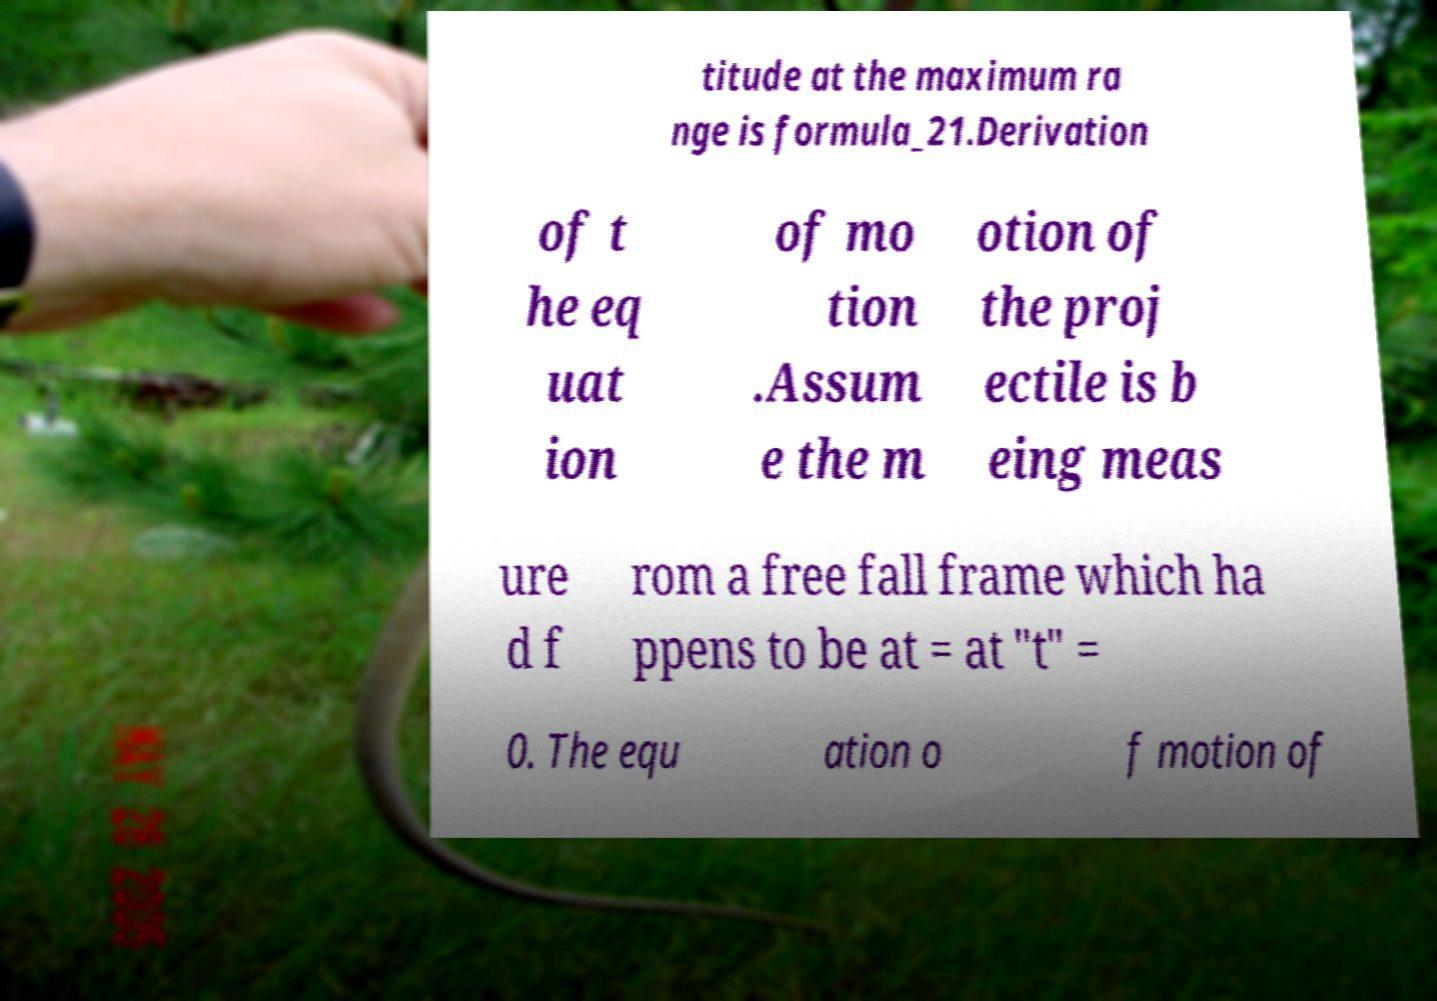Can you read and provide the text displayed in the image?This photo seems to have some interesting text. Can you extract and type it out for me? titude at the maximum ra nge is formula_21.Derivation of t he eq uat ion of mo tion .Assum e the m otion of the proj ectile is b eing meas ure d f rom a free fall frame which ha ppens to be at = at "t" = 0. The equ ation o f motion of 